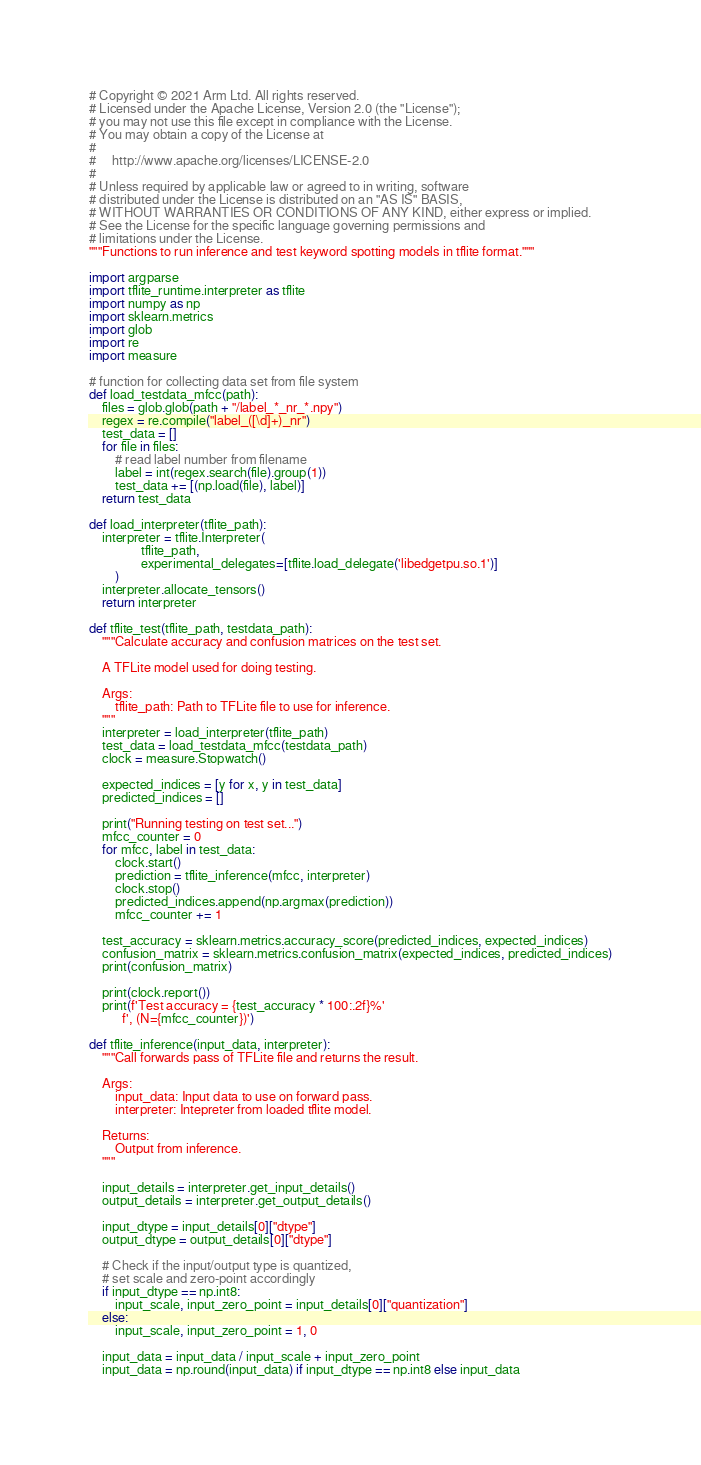Convert code to text. <code><loc_0><loc_0><loc_500><loc_500><_Python_># Copyright © 2021 Arm Ltd. All rights reserved.
# Licensed under the Apache License, Version 2.0 (the "License");
# you may not use this file except in compliance with the License.
# You may obtain a copy of the License at
#
#     http://www.apache.org/licenses/LICENSE-2.0
#
# Unless required by applicable law or agreed to in writing, software
# distributed under the License is distributed on an "AS IS" BASIS,
# WITHOUT WARRANTIES OR CONDITIONS OF ANY KIND, either express or implied.
# See the License for the specific language governing permissions and
# limitations under the License.
"""Functions to run inference and test keyword spotting models in tflite format."""

import argparse
import tflite_runtime.interpreter as tflite
import numpy as np
import sklearn.metrics
import glob
import re
import measure

# function for collecting data set from file system
def load_testdata_mfcc(path):
    files = glob.glob(path + "/label_*_nr_*.npy")
    regex = re.compile("label_([\d]+)_nr")
    test_data = []
    for file in files:
        # read label number from filename
        label = int(regex.search(file).group(1))
        test_data += [(np.load(file), label)]
    return test_data

def load_interpreter(tflite_path):
    interpreter = tflite.Interpreter(
                tflite_path, 
                experimental_delegates=[tflite.load_delegate('libedgetpu.so.1')]
        )
    interpreter.allocate_tensors()
    return interpreter

def tflite_test(tflite_path, testdata_path):
    """Calculate accuracy and confusion matrices on the test set.

    A TFLite model used for doing testing.

    Args:
        tflite_path: Path to TFLite file to use for inference.
    """
    interpreter = load_interpreter(tflite_path)
    test_data = load_testdata_mfcc(testdata_path)
    clock = measure.Stopwatch()

    expected_indices = [y for x, y in test_data]
    predicted_indices = []

    print("Running testing on test set...")
    mfcc_counter = 0
    for mfcc, label in test_data:
        clock.start()
        prediction = tflite_inference(mfcc, interpreter)
        clock.stop()
        predicted_indices.append(np.argmax(prediction))
        mfcc_counter += 1

    test_accuracy = sklearn.metrics.accuracy_score(predicted_indices, expected_indices)
    confusion_matrix = sklearn.metrics.confusion_matrix(expected_indices, predicted_indices)
    print(confusion_matrix)

    print(clock.report())
    print(f'Test accuracy = {test_accuracy * 100:.2f}%'
          f', (N={mfcc_counter})')

def tflite_inference(input_data, interpreter):
    """Call forwards pass of TFLite file and returns the result.

    Args:
        input_data: Input data to use on forward pass.
        interpreter: Intepreter from loaded tflite model.

    Returns:
        Output from inference.
    """

    input_details = interpreter.get_input_details()
    output_details = interpreter.get_output_details()

    input_dtype = input_details[0]["dtype"]
    output_dtype = output_details[0]["dtype"]

    # Check if the input/output type is quantized,
    # set scale and zero-point accordingly
    if input_dtype == np.int8:
        input_scale, input_zero_point = input_details[0]["quantization"]
    else:
        input_scale, input_zero_point = 1, 0

    input_data = input_data / input_scale + input_zero_point
    input_data = np.round(input_data) if input_dtype == np.int8 else input_data
</code> 